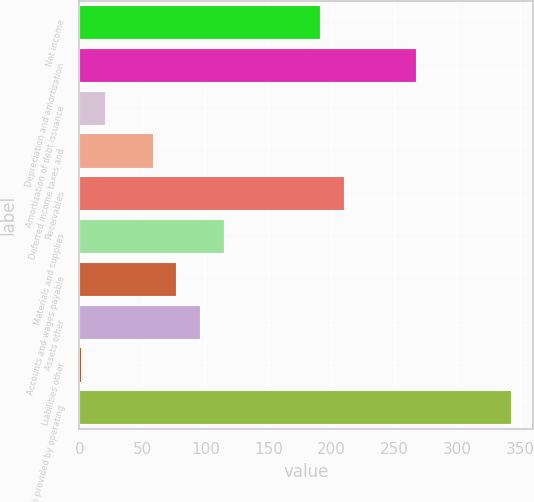Convert chart. <chart><loc_0><loc_0><loc_500><loc_500><bar_chart><fcel>Net income<fcel>Depreciation and amortization<fcel>Amortization of debt issuance<fcel>Deferred income taxes and<fcel>Receivables<fcel>Materials and supplies<fcel>Accounts and wages payable<fcel>Assets other<fcel>Liabilities other<fcel>Net cash provided by operating<nl><fcel>191<fcel>267<fcel>20<fcel>58<fcel>210<fcel>115<fcel>77<fcel>96<fcel>1<fcel>343<nl></chart> 